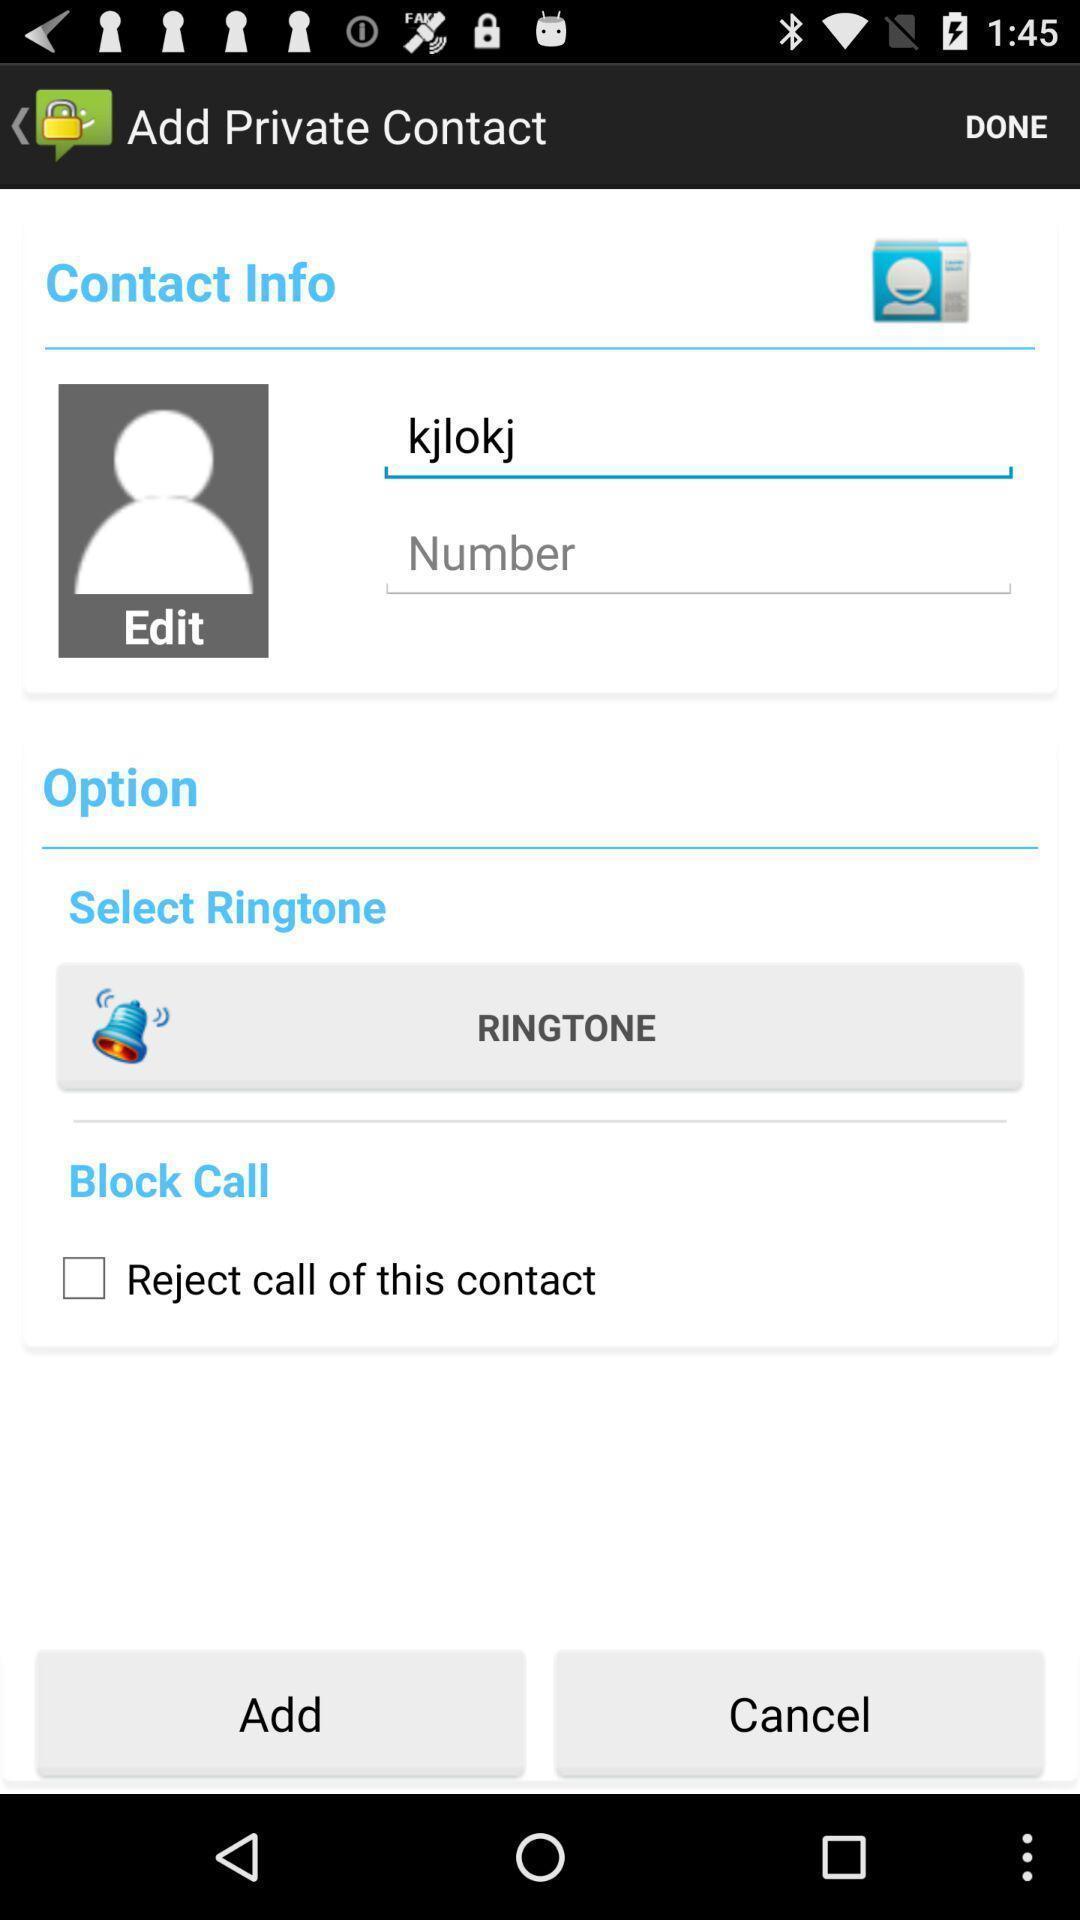Explain the elements present in this screenshot. Page showing settings for a contact. 